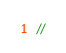<code> <loc_0><loc_0><loc_500><loc_500><_C_>//</code> 